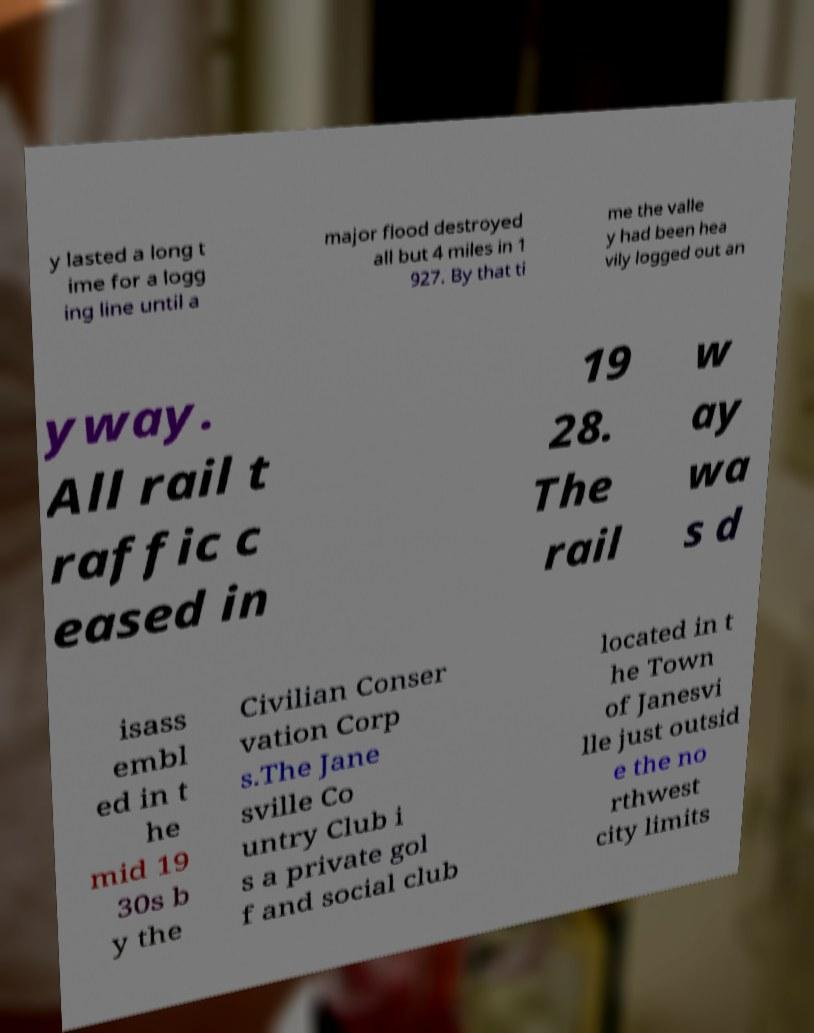Could you extract and type out the text from this image? y lasted a long t ime for a logg ing line until a major flood destroyed all but 4 miles in 1 927. By that ti me the valle y had been hea vily logged out an yway. All rail t raffic c eased in 19 28. The rail w ay wa s d isass embl ed in t he mid 19 30s b y the Civilian Conser vation Corp s.The Jane sville Co untry Club i s a private gol f and social club located in t he Town of Janesvi lle just outsid e the no rthwest city limits 